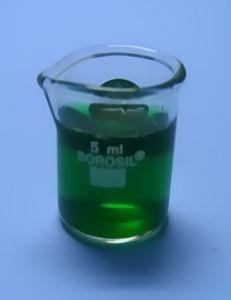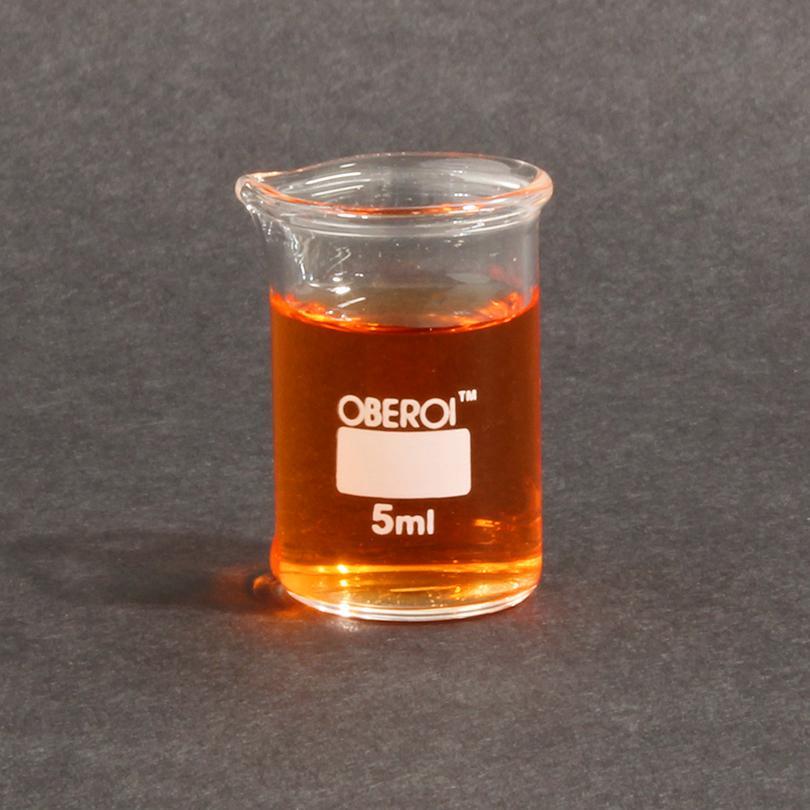The first image is the image on the left, the second image is the image on the right. Assess this claim about the two images: "There is no less than 14 filled beakers.". Correct or not? Answer yes or no. No. The first image is the image on the left, the second image is the image on the right. For the images shown, is this caption "There is green liquid in both images." true? Answer yes or no. No. 